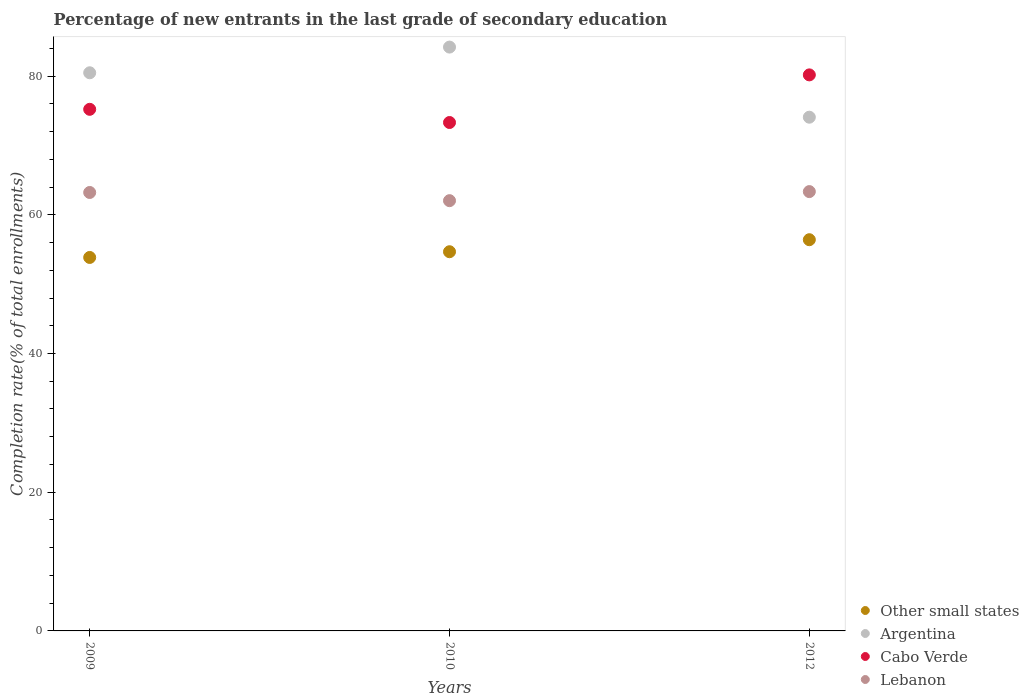How many different coloured dotlines are there?
Provide a succinct answer. 4. Is the number of dotlines equal to the number of legend labels?
Give a very brief answer. Yes. What is the percentage of new entrants in Cabo Verde in 2010?
Provide a succinct answer. 73.3. Across all years, what is the maximum percentage of new entrants in Lebanon?
Your response must be concise. 63.34. Across all years, what is the minimum percentage of new entrants in Other small states?
Offer a terse response. 53.85. What is the total percentage of new entrants in Cabo Verde in the graph?
Keep it short and to the point. 228.68. What is the difference between the percentage of new entrants in Other small states in 2009 and that in 2012?
Provide a succinct answer. -2.56. What is the difference between the percentage of new entrants in Other small states in 2012 and the percentage of new entrants in Argentina in 2010?
Provide a succinct answer. -27.77. What is the average percentage of new entrants in Argentina per year?
Offer a very short reply. 79.57. In the year 2012, what is the difference between the percentage of new entrants in Cabo Verde and percentage of new entrants in Other small states?
Your response must be concise. 23.76. In how many years, is the percentage of new entrants in Lebanon greater than 4 %?
Your response must be concise. 3. What is the ratio of the percentage of new entrants in Lebanon in 2009 to that in 2010?
Your answer should be very brief. 1.02. Is the percentage of new entrants in Other small states in 2009 less than that in 2010?
Your answer should be compact. Yes. What is the difference between the highest and the second highest percentage of new entrants in Other small states?
Your response must be concise. 1.73. What is the difference between the highest and the lowest percentage of new entrants in Cabo Verde?
Provide a short and direct response. 6.87. Is the sum of the percentage of new entrants in Argentina in 2010 and 2012 greater than the maximum percentage of new entrants in Lebanon across all years?
Give a very brief answer. Yes. Is it the case that in every year, the sum of the percentage of new entrants in Other small states and percentage of new entrants in Lebanon  is greater than the sum of percentage of new entrants in Cabo Verde and percentage of new entrants in Argentina?
Offer a very short reply. Yes. What is the difference between two consecutive major ticks on the Y-axis?
Offer a terse response. 20. What is the title of the graph?
Your answer should be compact. Percentage of new entrants in the last grade of secondary education. What is the label or title of the Y-axis?
Your answer should be compact. Completion rate(% of total enrollments). What is the Completion rate(% of total enrollments) in Other small states in 2009?
Provide a succinct answer. 53.85. What is the Completion rate(% of total enrollments) in Argentina in 2009?
Offer a very short reply. 80.47. What is the Completion rate(% of total enrollments) in Cabo Verde in 2009?
Make the answer very short. 75.2. What is the Completion rate(% of total enrollments) of Lebanon in 2009?
Offer a terse response. 63.22. What is the Completion rate(% of total enrollments) in Other small states in 2010?
Offer a very short reply. 54.67. What is the Completion rate(% of total enrollments) of Argentina in 2010?
Provide a succinct answer. 84.18. What is the Completion rate(% of total enrollments) of Cabo Verde in 2010?
Offer a very short reply. 73.3. What is the Completion rate(% of total enrollments) in Lebanon in 2010?
Ensure brevity in your answer.  62.03. What is the Completion rate(% of total enrollments) of Other small states in 2012?
Offer a very short reply. 56.4. What is the Completion rate(% of total enrollments) in Argentina in 2012?
Ensure brevity in your answer.  74.07. What is the Completion rate(% of total enrollments) in Cabo Verde in 2012?
Give a very brief answer. 80.17. What is the Completion rate(% of total enrollments) in Lebanon in 2012?
Give a very brief answer. 63.34. Across all years, what is the maximum Completion rate(% of total enrollments) in Other small states?
Offer a very short reply. 56.4. Across all years, what is the maximum Completion rate(% of total enrollments) of Argentina?
Provide a short and direct response. 84.18. Across all years, what is the maximum Completion rate(% of total enrollments) in Cabo Verde?
Offer a very short reply. 80.17. Across all years, what is the maximum Completion rate(% of total enrollments) of Lebanon?
Your answer should be compact. 63.34. Across all years, what is the minimum Completion rate(% of total enrollments) in Other small states?
Your answer should be compact. 53.85. Across all years, what is the minimum Completion rate(% of total enrollments) of Argentina?
Your answer should be very brief. 74.07. Across all years, what is the minimum Completion rate(% of total enrollments) of Cabo Verde?
Provide a short and direct response. 73.3. Across all years, what is the minimum Completion rate(% of total enrollments) in Lebanon?
Provide a short and direct response. 62.03. What is the total Completion rate(% of total enrollments) of Other small states in the graph?
Offer a very short reply. 164.92. What is the total Completion rate(% of total enrollments) of Argentina in the graph?
Give a very brief answer. 238.72. What is the total Completion rate(% of total enrollments) in Cabo Verde in the graph?
Your answer should be compact. 228.68. What is the total Completion rate(% of total enrollments) of Lebanon in the graph?
Provide a succinct answer. 188.59. What is the difference between the Completion rate(% of total enrollments) in Other small states in 2009 and that in 2010?
Provide a short and direct response. -0.82. What is the difference between the Completion rate(% of total enrollments) of Argentina in 2009 and that in 2010?
Your answer should be very brief. -3.7. What is the difference between the Completion rate(% of total enrollments) of Cabo Verde in 2009 and that in 2010?
Give a very brief answer. 1.9. What is the difference between the Completion rate(% of total enrollments) of Lebanon in 2009 and that in 2010?
Your answer should be very brief. 1.18. What is the difference between the Completion rate(% of total enrollments) of Other small states in 2009 and that in 2012?
Ensure brevity in your answer.  -2.56. What is the difference between the Completion rate(% of total enrollments) of Argentina in 2009 and that in 2012?
Provide a succinct answer. 6.4. What is the difference between the Completion rate(% of total enrollments) of Cabo Verde in 2009 and that in 2012?
Your response must be concise. -4.96. What is the difference between the Completion rate(% of total enrollments) of Lebanon in 2009 and that in 2012?
Provide a short and direct response. -0.13. What is the difference between the Completion rate(% of total enrollments) of Other small states in 2010 and that in 2012?
Give a very brief answer. -1.73. What is the difference between the Completion rate(% of total enrollments) in Argentina in 2010 and that in 2012?
Provide a succinct answer. 10.11. What is the difference between the Completion rate(% of total enrollments) in Cabo Verde in 2010 and that in 2012?
Give a very brief answer. -6.87. What is the difference between the Completion rate(% of total enrollments) of Lebanon in 2010 and that in 2012?
Your response must be concise. -1.31. What is the difference between the Completion rate(% of total enrollments) in Other small states in 2009 and the Completion rate(% of total enrollments) in Argentina in 2010?
Keep it short and to the point. -30.33. What is the difference between the Completion rate(% of total enrollments) of Other small states in 2009 and the Completion rate(% of total enrollments) of Cabo Verde in 2010?
Your response must be concise. -19.46. What is the difference between the Completion rate(% of total enrollments) of Other small states in 2009 and the Completion rate(% of total enrollments) of Lebanon in 2010?
Keep it short and to the point. -8.19. What is the difference between the Completion rate(% of total enrollments) in Argentina in 2009 and the Completion rate(% of total enrollments) in Cabo Verde in 2010?
Keep it short and to the point. 7.17. What is the difference between the Completion rate(% of total enrollments) in Argentina in 2009 and the Completion rate(% of total enrollments) in Lebanon in 2010?
Your answer should be compact. 18.44. What is the difference between the Completion rate(% of total enrollments) in Cabo Verde in 2009 and the Completion rate(% of total enrollments) in Lebanon in 2010?
Your answer should be very brief. 13.17. What is the difference between the Completion rate(% of total enrollments) of Other small states in 2009 and the Completion rate(% of total enrollments) of Argentina in 2012?
Make the answer very short. -20.22. What is the difference between the Completion rate(% of total enrollments) of Other small states in 2009 and the Completion rate(% of total enrollments) of Cabo Verde in 2012?
Your response must be concise. -26.32. What is the difference between the Completion rate(% of total enrollments) in Other small states in 2009 and the Completion rate(% of total enrollments) in Lebanon in 2012?
Offer a very short reply. -9.49. What is the difference between the Completion rate(% of total enrollments) of Argentina in 2009 and the Completion rate(% of total enrollments) of Cabo Verde in 2012?
Keep it short and to the point. 0.3. What is the difference between the Completion rate(% of total enrollments) in Argentina in 2009 and the Completion rate(% of total enrollments) in Lebanon in 2012?
Offer a terse response. 17.13. What is the difference between the Completion rate(% of total enrollments) of Cabo Verde in 2009 and the Completion rate(% of total enrollments) of Lebanon in 2012?
Offer a terse response. 11.86. What is the difference between the Completion rate(% of total enrollments) of Other small states in 2010 and the Completion rate(% of total enrollments) of Argentina in 2012?
Offer a terse response. -19.4. What is the difference between the Completion rate(% of total enrollments) of Other small states in 2010 and the Completion rate(% of total enrollments) of Cabo Verde in 2012?
Offer a terse response. -25.5. What is the difference between the Completion rate(% of total enrollments) of Other small states in 2010 and the Completion rate(% of total enrollments) of Lebanon in 2012?
Your answer should be compact. -8.67. What is the difference between the Completion rate(% of total enrollments) in Argentina in 2010 and the Completion rate(% of total enrollments) in Cabo Verde in 2012?
Offer a very short reply. 4.01. What is the difference between the Completion rate(% of total enrollments) in Argentina in 2010 and the Completion rate(% of total enrollments) in Lebanon in 2012?
Offer a very short reply. 20.83. What is the difference between the Completion rate(% of total enrollments) of Cabo Verde in 2010 and the Completion rate(% of total enrollments) of Lebanon in 2012?
Offer a terse response. 9.96. What is the average Completion rate(% of total enrollments) in Other small states per year?
Ensure brevity in your answer.  54.97. What is the average Completion rate(% of total enrollments) of Argentina per year?
Keep it short and to the point. 79.57. What is the average Completion rate(% of total enrollments) in Cabo Verde per year?
Your answer should be very brief. 76.23. What is the average Completion rate(% of total enrollments) in Lebanon per year?
Keep it short and to the point. 62.86. In the year 2009, what is the difference between the Completion rate(% of total enrollments) in Other small states and Completion rate(% of total enrollments) in Argentina?
Your answer should be very brief. -26.63. In the year 2009, what is the difference between the Completion rate(% of total enrollments) in Other small states and Completion rate(% of total enrollments) in Cabo Verde?
Your answer should be compact. -21.36. In the year 2009, what is the difference between the Completion rate(% of total enrollments) in Other small states and Completion rate(% of total enrollments) in Lebanon?
Provide a succinct answer. -9.37. In the year 2009, what is the difference between the Completion rate(% of total enrollments) of Argentina and Completion rate(% of total enrollments) of Cabo Verde?
Give a very brief answer. 5.27. In the year 2009, what is the difference between the Completion rate(% of total enrollments) of Argentina and Completion rate(% of total enrollments) of Lebanon?
Provide a short and direct response. 17.26. In the year 2009, what is the difference between the Completion rate(% of total enrollments) in Cabo Verde and Completion rate(% of total enrollments) in Lebanon?
Give a very brief answer. 11.99. In the year 2010, what is the difference between the Completion rate(% of total enrollments) of Other small states and Completion rate(% of total enrollments) of Argentina?
Make the answer very short. -29.5. In the year 2010, what is the difference between the Completion rate(% of total enrollments) of Other small states and Completion rate(% of total enrollments) of Cabo Verde?
Make the answer very short. -18.63. In the year 2010, what is the difference between the Completion rate(% of total enrollments) of Other small states and Completion rate(% of total enrollments) of Lebanon?
Offer a terse response. -7.36. In the year 2010, what is the difference between the Completion rate(% of total enrollments) of Argentina and Completion rate(% of total enrollments) of Cabo Verde?
Your answer should be compact. 10.87. In the year 2010, what is the difference between the Completion rate(% of total enrollments) of Argentina and Completion rate(% of total enrollments) of Lebanon?
Offer a very short reply. 22.14. In the year 2010, what is the difference between the Completion rate(% of total enrollments) in Cabo Verde and Completion rate(% of total enrollments) in Lebanon?
Give a very brief answer. 11.27. In the year 2012, what is the difference between the Completion rate(% of total enrollments) of Other small states and Completion rate(% of total enrollments) of Argentina?
Your response must be concise. -17.66. In the year 2012, what is the difference between the Completion rate(% of total enrollments) in Other small states and Completion rate(% of total enrollments) in Cabo Verde?
Provide a short and direct response. -23.76. In the year 2012, what is the difference between the Completion rate(% of total enrollments) of Other small states and Completion rate(% of total enrollments) of Lebanon?
Your answer should be compact. -6.94. In the year 2012, what is the difference between the Completion rate(% of total enrollments) of Argentina and Completion rate(% of total enrollments) of Cabo Verde?
Ensure brevity in your answer.  -6.1. In the year 2012, what is the difference between the Completion rate(% of total enrollments) in Argentina and Completion rate(% of total enrollments) in Lebanon?
Offer a very short reply. 10.73. In the year 2012, what is the difference between the Completion rate(% of total enrollments) in Cabo Verde and Completion rate(% of total enrollments) in Lebanon?
Your answer should be compact. 16.83. What is the ratio of the Completion rate(% of total enrollments) in Other small states in 2009 to that in 2010?
Your response must be concise. 0.98. What is the ratio of the Completion rate(% of total enrollments) of Argentina in 2009 to that in 2010?
Provide a succinct answer. 0.96. What is the ratio of the Completion rate(% of total enrollments) of Cabo Verde in 2009 to that in 2010?
Provide a short and direct response. 1.03. What is the ratio of the Completion rate(% of total enrollments) of Other small states in 2009 to that in 2012?
Your answer should be very brief. 0.95. What is the ratio of the Completion rate(% of total enrollments) of Argentina in 2009 to that in 2012?
Your response must be concise. 1.09. What is the ratio of the Completion rate(% of total enrollments) in Cabo Verde in 2009 to that in 2012?
Make the answer very short. 0.94. What is the ratio of the Completion rate(% of total enrollments) in Lebanon in 2009 to that in 2012?
Provide a short and direct response. 1. What is the ratio of the Completion rate(% of total enrollments) of Other small states in 2010 to that in 2012?
Your answer should be compact. 0.97. What is the ratio of the Completion rate(% of total enrollments) of Argentina in 2010 to that in 2012?
Offer a terse response. 1.14. What is the ratio of the Completion rate(% of total enrollments) in Cabo Verde in 2010 to that in 2012?
Offer a very short reply. 0.91. What is the ratio of the Completion rate(% of total enrollments) of Lebanon in 2010 to that in 2012?
Your answer should be compact. 0.98. What is the difference between the highest and the second highest Completion rate(% of total enrollments) in Other small states?
Give a very brief answer. 1.73. What is the difference between the highest and the second highest Completion rate(% of total enrollments) in Argentina?
Keep it short and to the point. 3.7. What is the difference between the highest and the second highest Completion rate(% of total enrollments) of Cabo Verde?
Ensure brevity in your answer.  4.96. What is the difference between the highest and the second highest Completion rate(% of total enrollments) of Lebanon?
Keep it short and to the point. 0.13. What is the difference between the highest and the lowest Completion rate(% of total enrollments) in Other small states?
Your answer should be compact. 2.56. What is the difference between the highest and the lowest Completion rate(% of total enrollments) of Argentina?
Your answer should be compact. 10.11. What is the difference between the highest and the lowest Completion rate(% of total enrollments) of Cabo Verde?
Ensure brevity in your answer.  6.87. What is the difference between the highest and the lowest Completion rate(% of total enrollments) in Lebanon?
Make the answer very short. 1.31. 